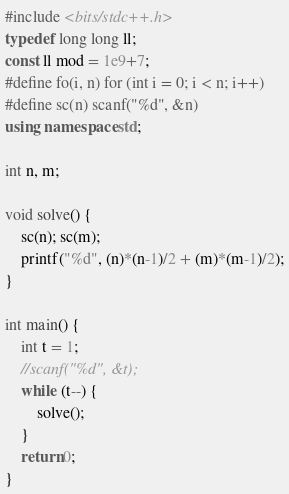Convert code to text. <code><loc_0><loc_0><loc_500><loc_500><_C++_>#include <bits/stdc++.h>
typedef long long ll; 
const ll mod = 1e9+7;
#define fo(i, n) for (int i = 0; i < n; i++)
#define sc(n) scanf("%d", &n) 
using namespace std;

int n, m;

void solve() {
    sc(n); sc(m);
    printf("%d", (n)*(n-1)/2 + (m)*(m-1)/2);
}

int main() {
    int t = 1;
    //scanf("%d", &t);
    while (t--) {
        solve();
    }
    return 0;
}</code> 